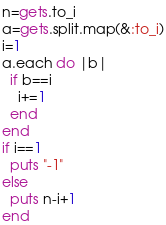Convert code to text. <code><loc_0><loc_0><loc_500><loc_500><_Ruby_>n=gets.to_i
a=gets.split.map(&:to_i)
i=1
a.each do |b|
  if b==i
    i+=1
  end
end
if i==1
  puts "-1"
else
  puts n-i+1
end

</code> 